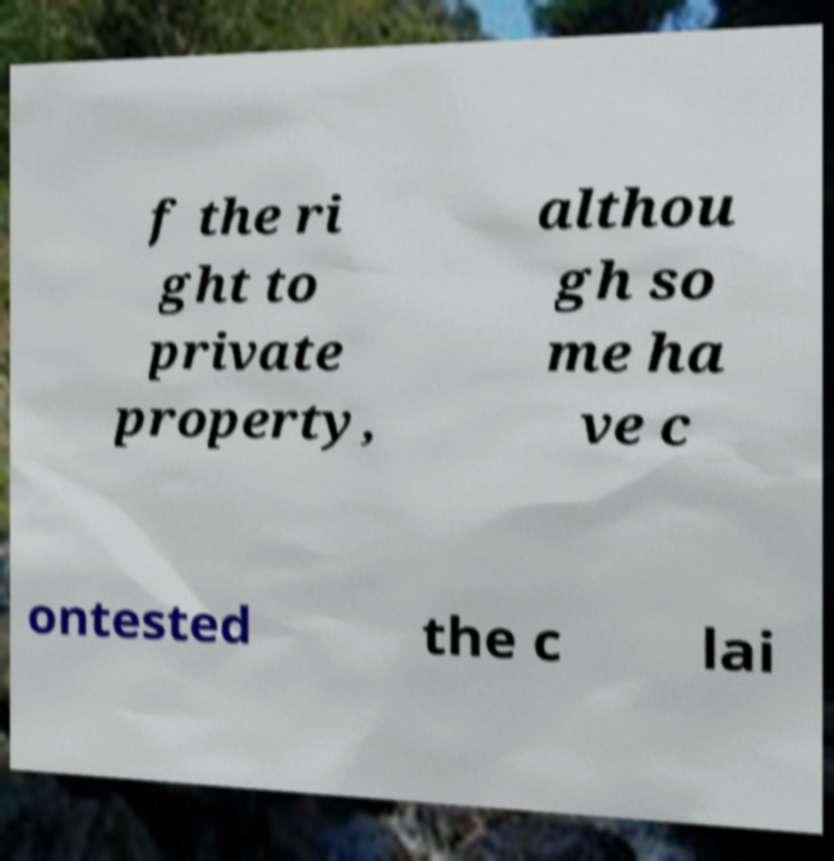Can you accurately transcribe the text from the provided image for me? f the ri ght to private property, althou gh so me ha ve c ontested the c lai 